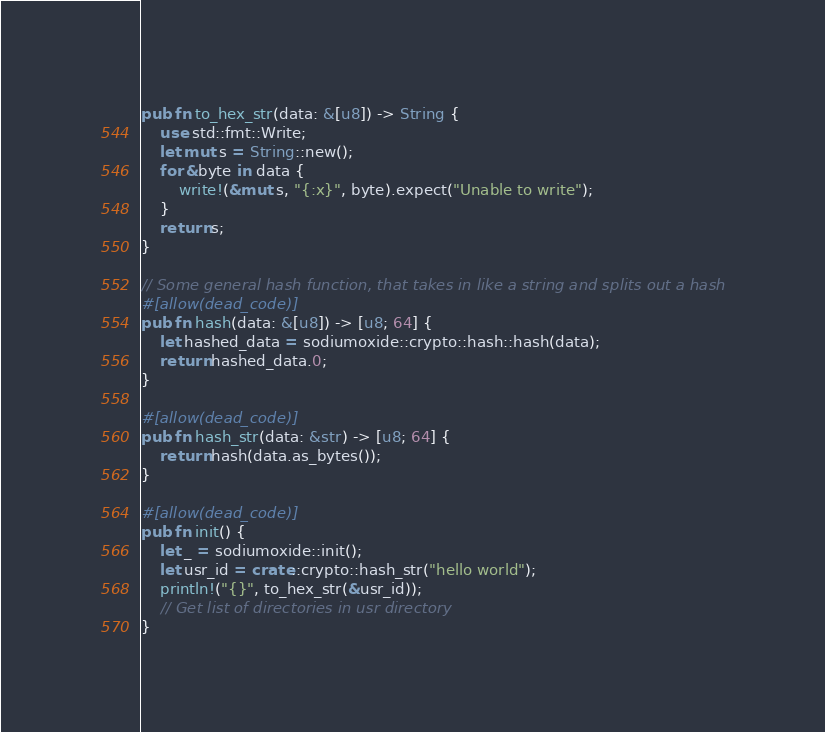<code> <loc_0><loc_0><loc_500><loc_500><_Rust_>pub fn to_hex_str(data: &[u8]) -> String {
    use std::fmt::Write;
    let mut s = String::new();
    for &byte in data {
        write!(&mut s, "{:x}", byte).expect("Unable to write");
    }
    return s;
}

// Some general hash function, that takes in like a string and splits out a hash
#[allow(dead_code)]
pub fn hash(data: &[u8]) -> [u8; 64] {
    let hashed_data = sodiumoxide::crypto::hash::hash(data);
    return hashed_data.0;
}

#[allow(dead_code)]
pub fn hash_str(data: &str) -> [u8; 64] {
    return hash(data.as_bytes());
}

#[allow(dead_code)]
pub fn init() {
    let _ = sodiumoxide::init();
    let usr_id = crate::crypto::hash_str("hello world");
    println!("{}", to_hex_str(&usr_id));
    // Get list of directories in usr directory
}
</code> 